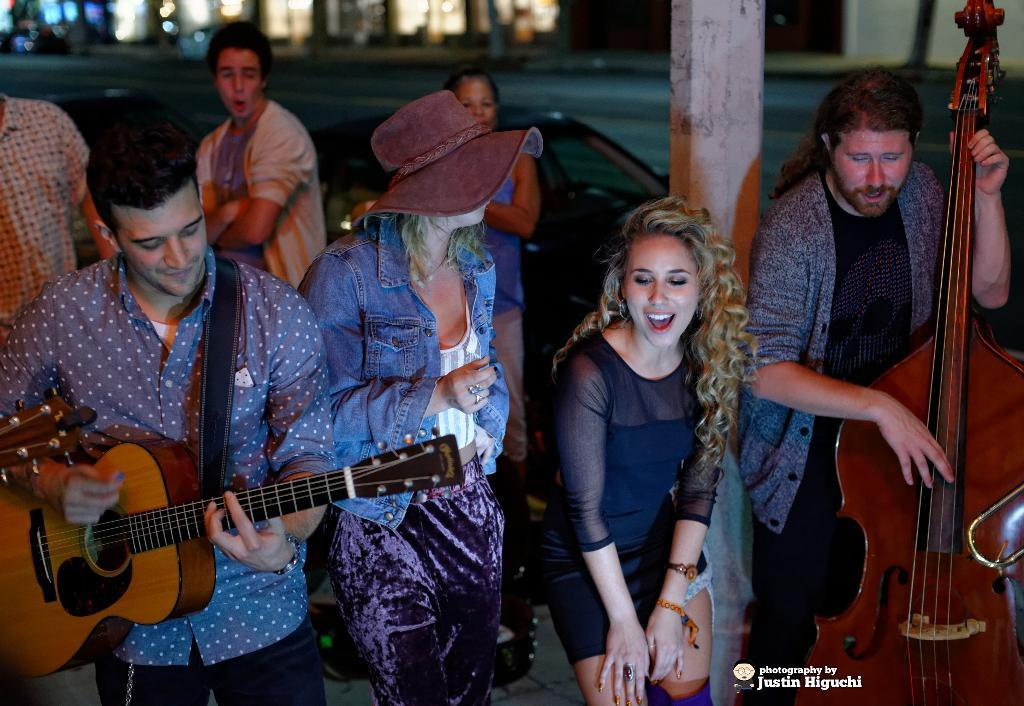How many people are in the image? There are many people in the image. What are the people in the image doing? The people are dancing. Can you describe any specific activity involving musical instruments? Two people are holding a guitar and playing it. What type of eggnog is being served to the dancers in the image? There is no mention of eggnog or any beverage being served in the image. 